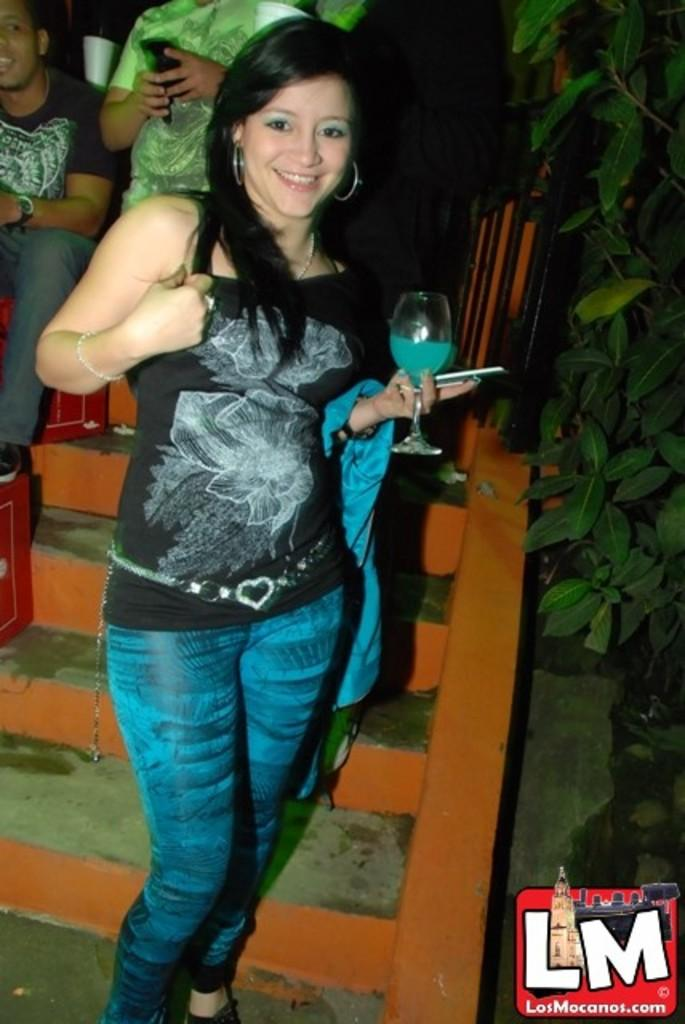Who is the main subject in the image? There is a girl in the image. What is the girl doing in the image? The girl is standing behind steps. What is the girl holding in the image? The girl is holding a glass of drink. What type of hat is the girl wearing in the image? There is no hat present in the image; the girl is not wearing a hat. 